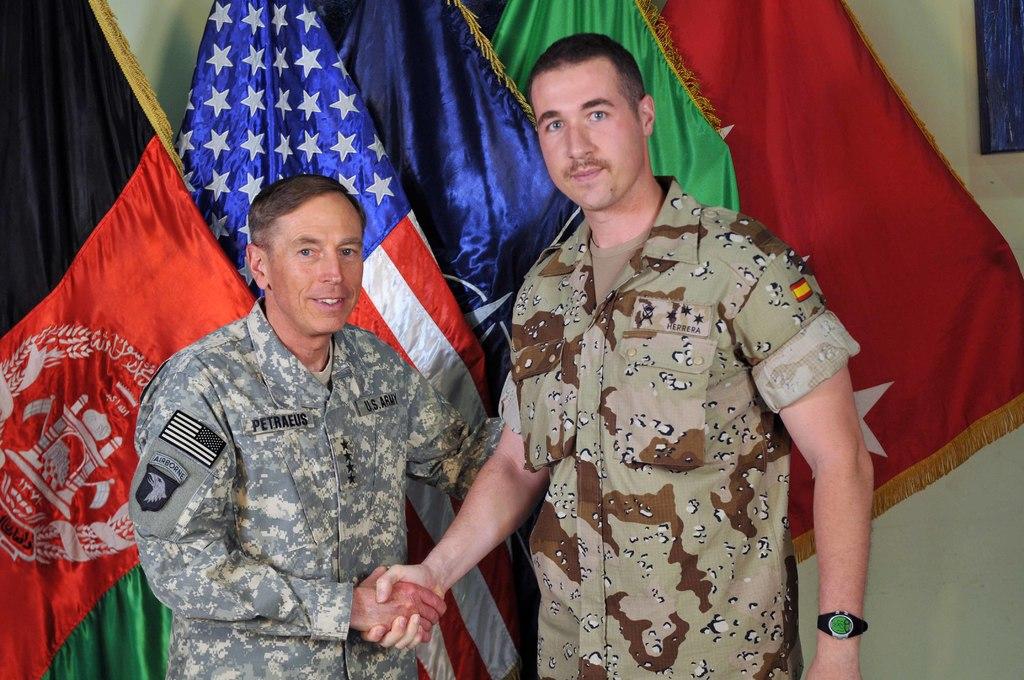What is the left mans last name?
Your response must be concise. Petraeus. 